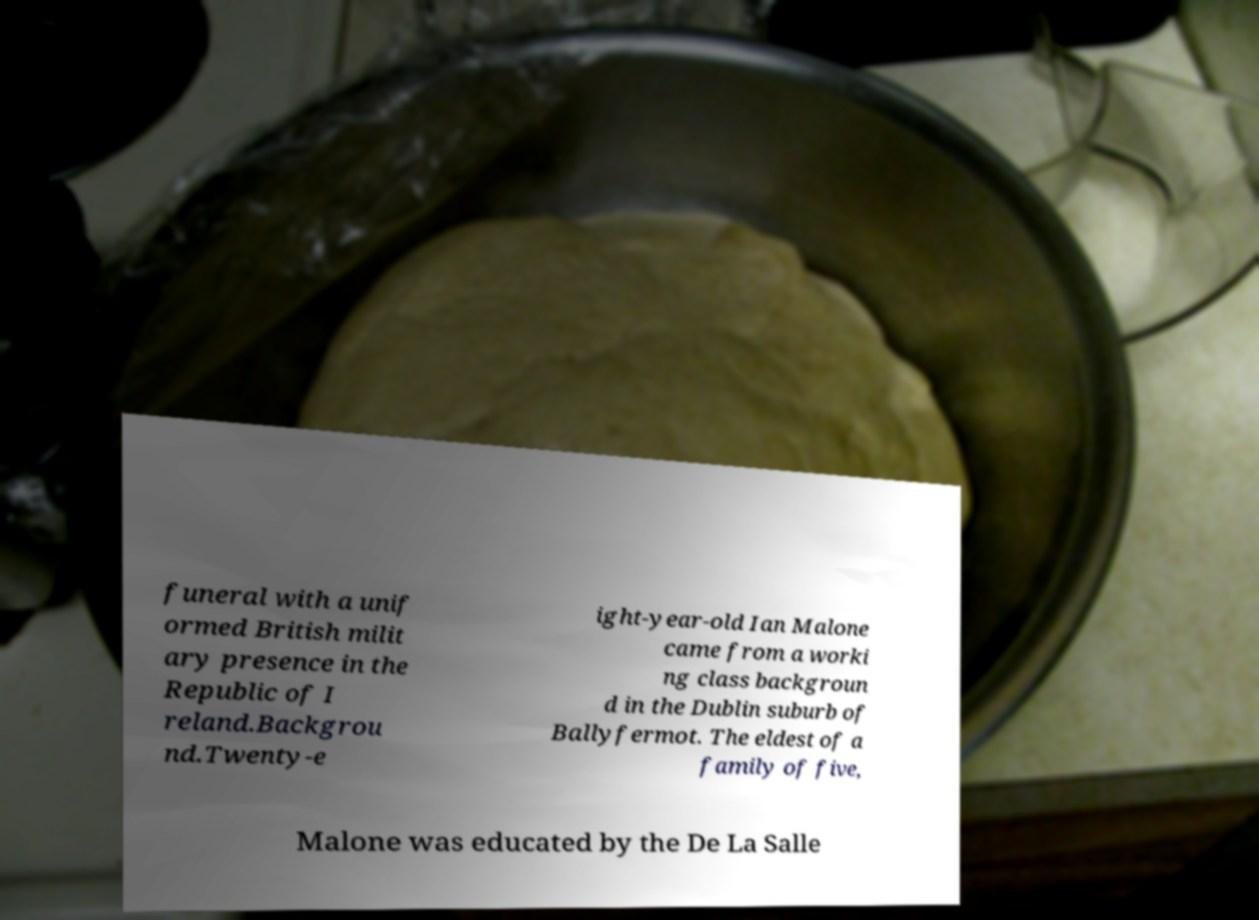Can you accurately transcribe the text from the provided image for me? funeral with a unif ormed British milit ary presence in the Republic of I reland.Backgrou nd.Twenty-e ight-year-old Ian Malone came from a worki ng class backgroun d in the Dublin suburb of Ballyfermot. The eldest of a family of five, Malone was educated by the De La Salle 